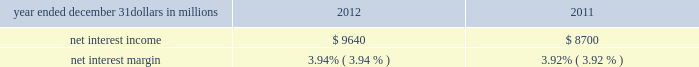Consolidated income statement review our consolidated income statement is presented in item 8 of this report .
Net income for 2012 was $ 3.0 billion compared with $ 3.1 billion for 2011 .
Revenue growth of 8 percent and a decline in the provision for credit losses were more than offset by a 16 percent increase in noninterest expense in 2012 compared to 2011 .
Further detail is included in the net interest income , noninterest income , provision for credit losses and noninterest expense portions of this consolidated income statement review .
Net interest income table 2 : net interest income and net interest margin year ended december 31 dollars in millions 2012 2011 .
Changes in net interest income and margin result from the interaction of the volume and composition of interest-earning assets and related yields , interest-bearing liabilities and related rates paid , and noninterest-bearing sources of funding .
See the statistical information ( unaudited ) 2013 average consolidated balance sheet and net interest analysis and analysis of year-to-year changes in net interest income in item 8 of this report and the discussion of purchase accounting accretion of purchased impaired loans in the consolidated balance sheet review in this item 7 for additional information .
The increase in net interest income in 2012 compared with 2011 was primarily due to the impact of the rbc bank ( usa ) acquisition , organic loan growth and lower funding costs .
Purchase accounting accretion remained stable at $ 1.1 billion in both periods .
The net interest margin was 3.94% ( 3.94 % ) for 2012 and 3.92% ( 3.92 % ) for 2011 .
The increase in the comparison was primarily due to a decrease in the weighted-average rate accrued on total interest- bearing liabilities of 29 basis points , largely offset by a 21 basis point decrease on the yield on total interest-earning assets .
The decrease in the rate on interest-bearing liabilities was primarily due to the runoff of maturing retail certificates of deposit and the redemption of additional trust preferred and hybrid capital securities during 2012 , in addition to an increase in fhlb borrowings and commercial paper as lower-cost funding sources .
The decrease in the yield on interest-earning assets was primarily due to lower rates on new loan volume and lower yields on new securities in the current low rate environment .
With respect to the first quarter of 2013 , we expect net interest income to decline by two to three percent compared to fourth quarter 2012 net interest income of $ 2.4 billion , due to a decrease in purchase accounting accretion of up to $ 50 to $ 60 million , including lower expected cash recoveries .
For the full year 2013 , we expect net interest income to decrease compared with 2012 , assuming an expected decline in purchase accounting accretion of approximately $ 400 million , while core net interest income is expected to increase in the year-over-year comparison .
We believe our net interest margin will come under pressure in 2013 , due to the expected decline in purchase accounting accretion and assuming that the current low rate environment continues .
Noninterest income noninterest income totaled $ 5.9 billion for 2012 and $ 5.6 billion for 2011 .
The overall increase in the comparison was primarily due to an increase in residential mortgage loan sales revenue driven by higher loan origination volume , gains on sales of visa class b common shares and higher corporate service fees , largely offset by higher provision for residential mortgage repurchase obligations .
Asset management revenue , including blackrock , totaled $ 1.2 billion in 2012 compared with $ 1.1 billion in 2011 .
This increase was primarily due to higher earnings from our blackrock investment .
Discretionary assets under management increased to $ 112 billion at december 31 , 2012 compared with $ 107 billion at december 31 , 2011 driven by stronger average equity markets , positive net flows and strong sales performance .
For 2012 , consumer services fees were $ 1.1 billion compared with $ 1.2 billion in 2011 .
The decline reflected the regulatory impact of lower interchange fees on debit card transactions partially offset by customer growth .
As further discussed in the retail banking portion of the business segments review section of this item 7 , the dodd-frank limits on interchange rates were effective october 1 , 2011 and had a negative impact on revenue of approximately $ 314 million in 2012 and $ 75 million in 2011 .
This impact was partially offset by higher volumes of merchant , customer credit card and debit card transactions and the impact of the rbc bank ( usa ) acquisition .
Corporate services revenue increased by $ .3 billion , or 30 percent , to $ 1.2 billion in 2012 compared with $ .9 billion in 2011 due to higher commercial mortgage servicing revenue and higher merger and acquisition advisory fees in 2012 .
The major components of corporate services revenue are treasury management revenue , corporate finance fees , including revenue from capital markets-related products and services , and commercial mortgage servicing revenue , including commercial mortgage banking activities .
See the product revenue portion of this consolidated income statement review for further detail .
The pnc financial services group , inc .
2013 form 10-k 39 .
What was the change in millions in net interest income between 2011 and 2012? 
Computations: (9640 - 8700)
Answer: 940.0. 